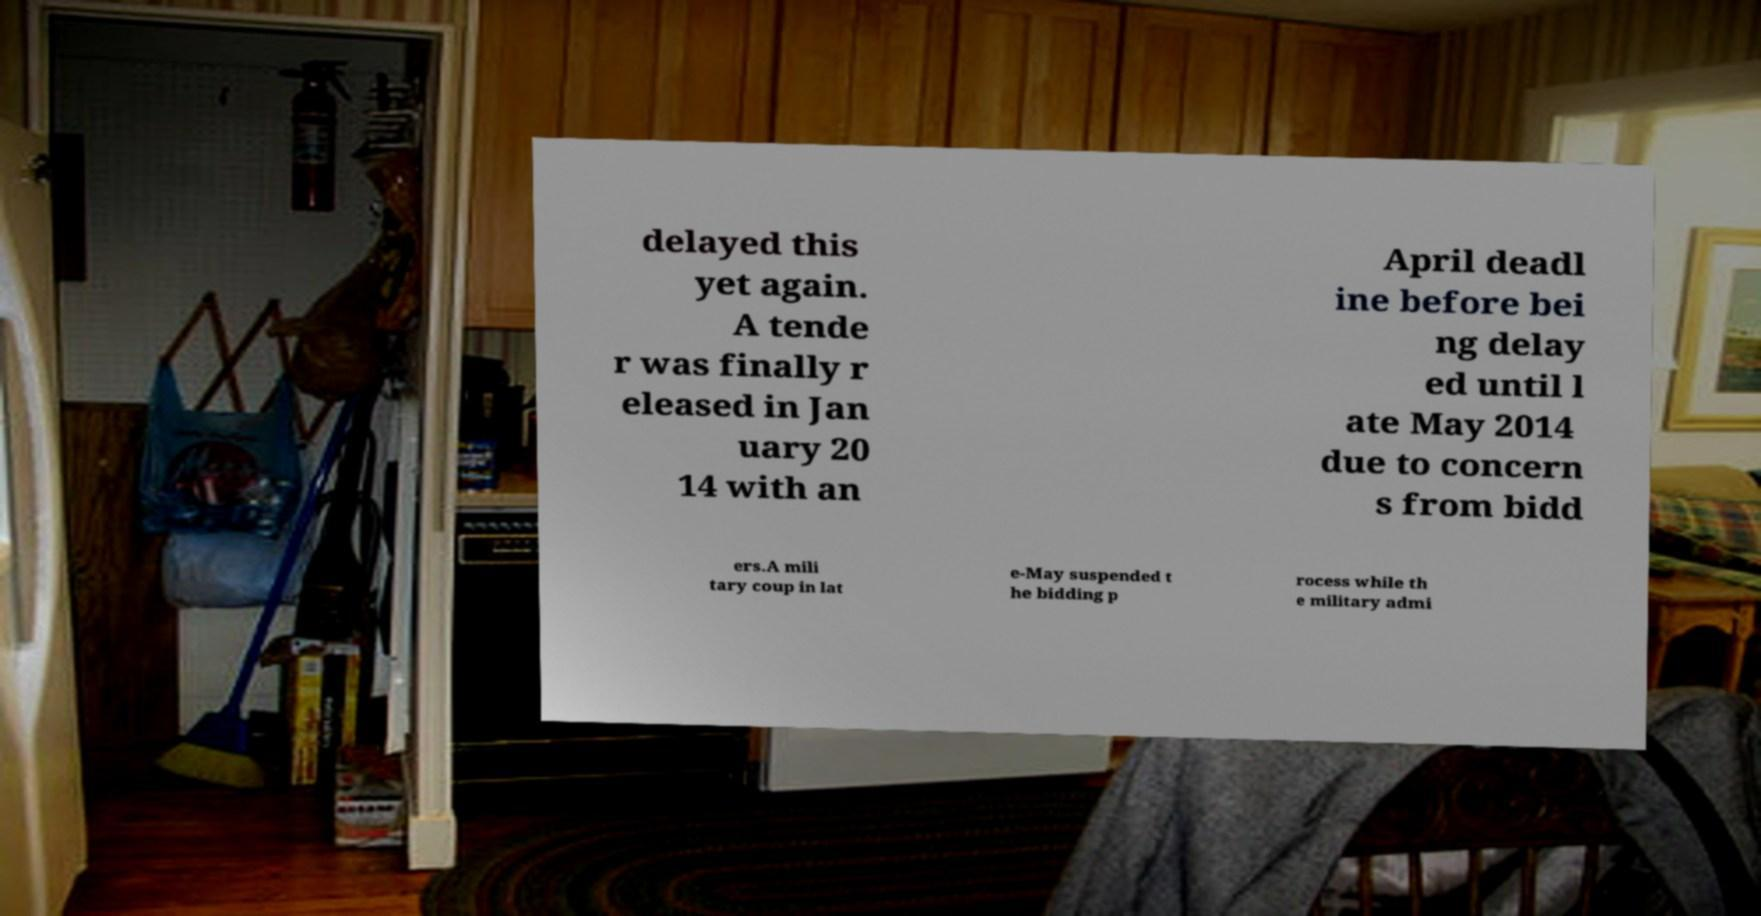There's text embedded in this image that I need extracted. Can you transcribe it verbatim? delayed this yet again. A tende r was finally r eleased in Jan uary 20 14 with an April deadl ine before bei ng delay ed until l ate May 2014 due to concern s from bidd ers.A mili tary coup in lat e-May suspended t he bidding p rocess while th e military admi 